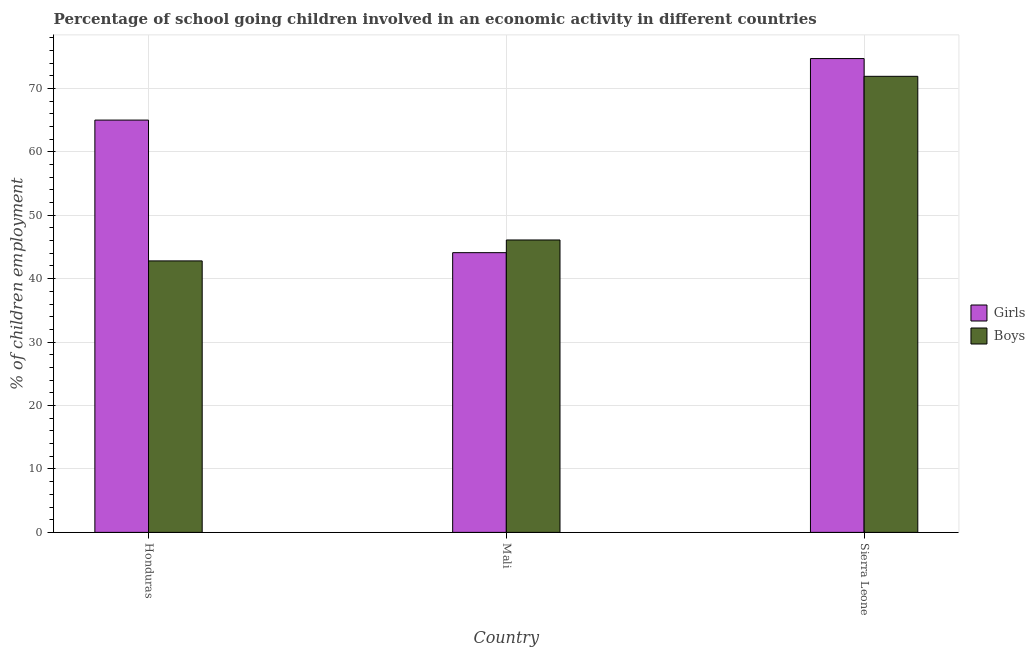How many groups of bars are there?
Make the answer very short. 3. Are the number of bars on each tick of the X-axis equal?
Make the answer very short. Yes. How many bars are there on the 1st tick from the left?
Give a very brief answer. 2. What is the label of the 2nd group of bars from the left?
Provide a short and direct response. Mali. Across all countries, what is the maximum percentage of school going boys?
Give a very brief answer. 71.9. Across all countries, what is the minimum percentage of school going girls?
Provide a short and direct response. 44.1. In which country was the percentage of school going boys maximum?
Give a very brief answer. Sierra Leone. In which country was the percentage of school going boys minimum?
Ensure brevity in your answer.  Honduras. What is the total percentage of school going girls in the graph?
Provide a short and direct response. 183.8. What is the difference between the percentage of school going girls in Honduras and that in Mali?
Give a very brief answer. 20.9. What is the difference between the percentage of school going girls in Sierra Leone and the percentage of school going boys in Mali?
Keep it short and to the point. 28.6. What is the average percentage of school going boys per country?
Provide a succinct answer. 53.6. What is the difference between the percentage of school going girls and percentage of school going boys in Mali?
Give a very brief answer. -2. In how many countries, is the percentage of school going girls greater than 76 %?
Provide a succinct answer. 0. What is the ratio of the percentage of school going girls in Honduras to that in Mali?
Your response must be concise. 1.47. Is the difference between the percentage of school going girls in Honduras and Sierra Leone greater than the difference between the percentage of school going boys in Honduras and Sierra Leone?
Your answer should be very brief. Yes. What is the difference between the highest and the second highest percentage of school going girls?
Your answer should be very brief. 9.7. What is the difference between the highest and the lowest percentage of school going boys?
Your answer should be very brief. 29.1. Is the sum of the percentage of school going boys in Mali and Sierra Leone greater than the maximum percentage of school going girls across all countries?
Your response must be concise. Yes. What does the 2nd bar from the left in Honduras represents?
Provide a short and direct response. Boys. What does the 1st bar from the right in Sierra Leone represents?
Keep it short and to the point. Boys. Are all the bars in the graph horizontal?
Make the answer very short. No. How many countries are there in the graph?
Provide a succinct answer. 3. What is the difference between two consecutive major ticks on the Y-axis?
Make the answer very short. 10. Where does the legend appear in the graph?
Ensure brevity in your answer.  Center right. What is the title of the graph?
Provide a short and direct response. Percentage of school going children involved in an economic activity in different countries. Does "Fertility rate" appear as one of the legend labels in the graph?
Offer a very short reply. No. What is the label or title of the Y-axis?
Offer a terse response. % of children employment. What is the % of children employment in Girls in Honduras?
Ensure brevity in your answer.  65. What is the % of children employment in Boys in Honduras?
Keep it short and to the point. 42.8. What is the % of children employment of Girls in Mali?
Give a very brief answer. 44.1. What is the % of children employment of Boys in Mali?
Ensure brevity in your answer.  46.1. What is the % of children employment in Girls in Sierra Leone?
Your answer should be compact. 74.7. What is the % of children employment of Boys in Sierra Leone?
Provide a succinct answer. 71.9. Across all countries, what is the maximum % of children employment of Girls?
Your answer should be compact. 74.7. Across all countries, what is the maximum % of children employment of Boys?
Give a very brief answer. 71.9. Across all countries, what is the minimum % of children employment of Girls?
Offer a very short reply. 44.1. Across all countries, what is the minimum % of children employment in Boys?
Provide a succinct answer. 42.8. What is the total % of children employment of Girls in the graph?
Your response must be concise. 183.8. What is the total % of children employment in Boys in the graph?
Ensure brevity in your answer.  160.8. What is the difference between the % of children employment of Girls in Honduras and that in Mali?
Your answer should be very brief. 20.9. What is the difference between the % of children employment in Boys in Honduras and that in Mali?
Give a very brief answer. -3.3. What is the difference between the % of children employment in Boys in Honduras and that in Sierra Leone?
Make the answer very short. -29.1. What is the difference between the % of children employment of Girls in Mali and that in Sierra Leone?
Keep it short and to the point. -30.6. What is the difference between the % of children employment in Boys in Mali and that in Sierra Leone?
Your answer should be very brief. -25.8. What is the difference between the % of children employment in Girls in Honduras and the % of children employment in Boys in Sierra Leone?
Offer a terse response. -6.9. What is the difference between the % of children employment in Girls in Mali and the % of children employment in Boys in Sierra Leone?
Offer a very short reply. -27.8. What is the average % of children employment in Girls per country?
Offer a very short reply. 61.27. What is the average % of children employment of Boys per country?
Give a very brief answer. 53.6. What is the difference between the % of children employment in Girls and % of children employment in Boys in Mali?
Your response must be concise. -2. What is the ratio of the % of children employment in Girls in Honduras to that in Mali?
Your answer should be very brief. 1.47. What is the ratio of the % of children employment of Boys in Honduras to that in Mali?
Keep it short and to the point. 0.93. What is the ratio of the % of children employment in Girls in Honduras to that in Sierra Leone?
Your answer should be compact. 0.87. What is the ratio of the % of children employment in Boys in Honduras to that in Sierra Leone?
Offer a terse response. 0.6. What is the ratio of the % of children employment of Girls in Mali to that in Sierra Leone?
Keep it short and to the point. 0.59. What is the ratio of the % of children employment of Boys in Mali to that in Sierra Leone?
Your answer should be very brief. 0.64. What is the difference between the highest and the second highest % of children employment of Boys?
Offer a terse response. 25.8. What is the difference between the highest and the lowest % of children employment in Girls?
Provide a short and direct response. 30.6. What is the difference between the highest and the lowest % of children employment of Boys?
Provide a succinct answer. 29.1. 